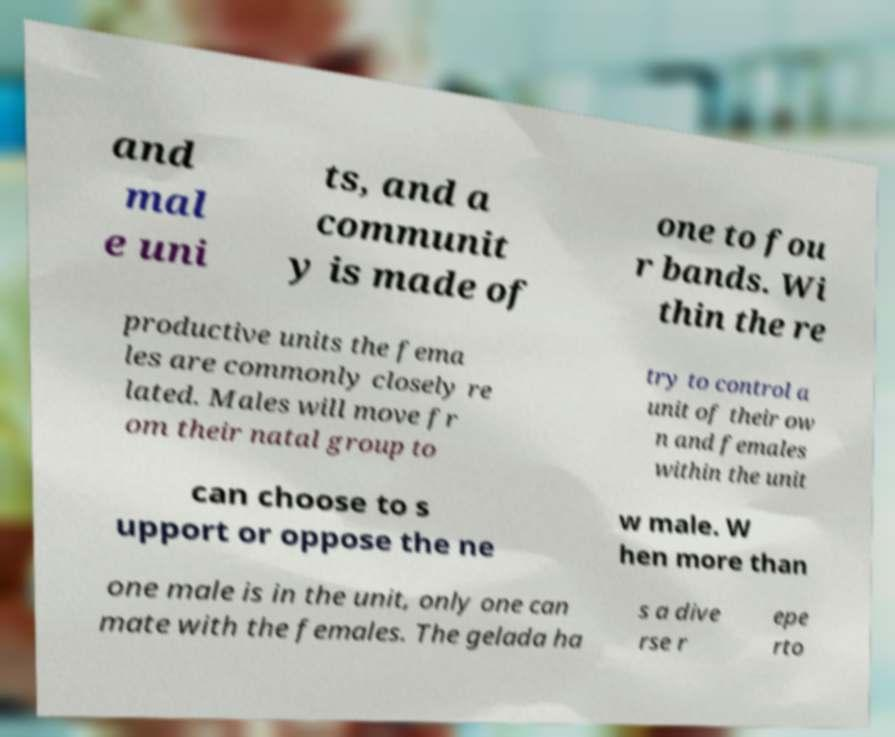Can you accurately transcribe the text from the provided image for me? and mal e uni ts, and a communit y is made of one to fou r bands. Wi thin the re productive units the fema les are commonly closely re lated. Males will move fr om their natal group to try to control a unit of their ow n and females within the unit can choose to s upport or oppose the ne w male. W hen more than one male is in the unit, only one can mate with the females. The gelada ha s a dive rse r epe rto 